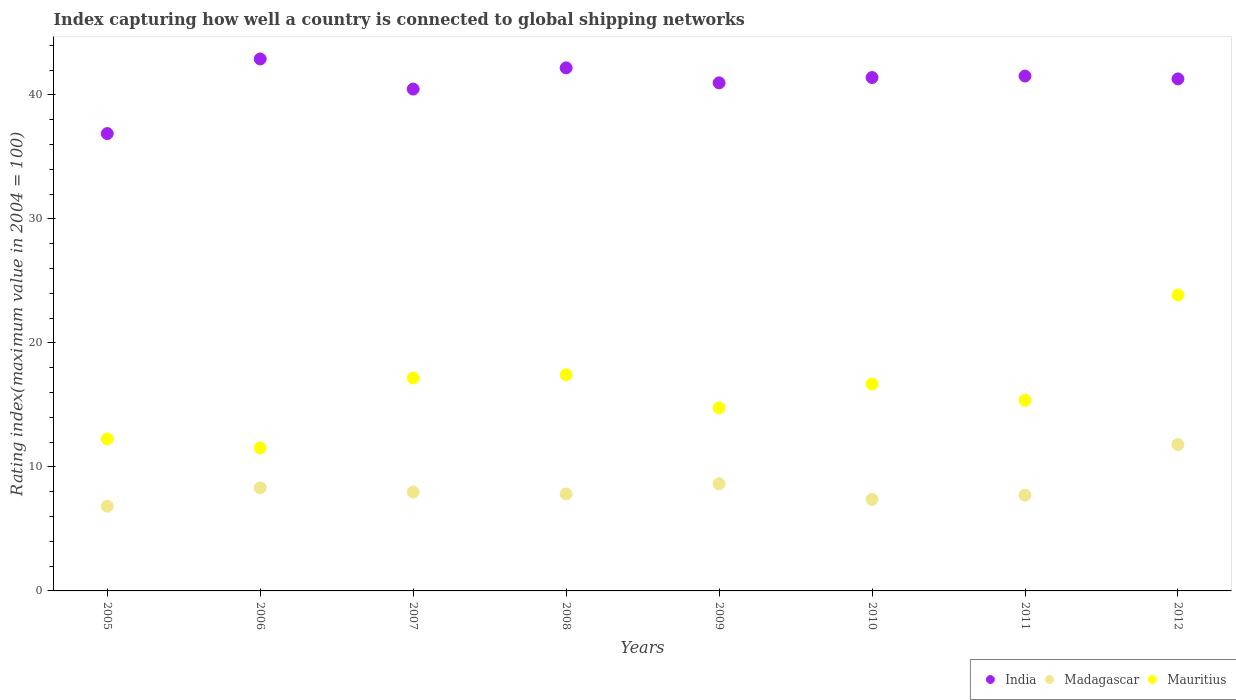How many different coloured dotlines are there?
Ensure brevity in your answer.  3. Is the number of dotlines equal to the number of legend labels?
Your response must be concise. Yes. What is the rating index in Madagascar in 2012?
Provide a short and direct response. 11.8. Across all years, what is the maximum rating index in Madagascar?
Provide a succinct answer. 11.8. Across all years, what is the minimum rating index in Madagascar?
Offer a very short reply. 6.83. In which year was the rating index in Madagascar maximum?
Your response must be concise. 2012. What is the total rating index in Mauritius in the graph?
Your answer should be very brief. 129.06. What is the difference between the rating index in Madagascar in 2007 and that in 2012?
Offer a terse response. -3.83. What is the difference between the rating index in India in 2011 and the rating index in Mauritius in 2007?
Offer a terse response. 24.35. What is the average rating index in Madagascar per year?
Ensure brevity in your answer.  8.31. In the year 2005, what is the difference between the rating index in India and rating index in Mauritius?
Your answer should be very brief. 24.62. In how many years, is the rating index in India greater than 40?
Offer a terse response. 7. What is the ratio of the rating index in Madagascar in 2007 to that in 2009?
Provide a succinct answer. 0.92. What is the difference between the highest and the second highest rating index in India?
Keep it short and to the point. 0.72. What is the difference between the highest and the lowest rating index in Madagascar?
Your answer should be compact. 4.97. In how many years, is the rating index in Mauritius greater than the average rating index in Mauritius taken over all years?
Your answer should be very brief. 4. Is it the case that in every year, the sum of the rating index in Mauritius and rating index in Madagascar  is greater than the rating index in India?
Ensure brevity in your answer.  No. Does the rating index in Mauritius monotonically increase over the years?
Offer a terse response. No. Is the rating index in India strictly less than the rating index in Madagascar over the years?
Make the answer very short. No. How many dotlines are there?
Your response must be concise. 3. Does the graph contain grids?
Make the answer very short. No. How many legend labels are there?
Make the answer very short. 3. What is the title of the graph?
Give a very brief answer. Index capturing how well a country is connected to global shipping networks. Does "High income: nonOECD" appear as one of the legend labels in the graph?
Your answer should be very brief. No. What is the label or title of the Y-axis?
Your answer should be compact. Rating index(maximum value in 2004 = 100). What is the Rating index(maximum value in 2004 = 100) in India in 2005?
Provide a succinct answer. 36.88. What is the Rating index(maximum value in 2004 = 100) of Madagascar in 2005?
Ensure brevity in your answer.  6.83. What is the Rating index(maximum value in 2004 = 100) of Mauritius in 2005?
Provide a short and direct response. 12.26. What is the Rating index(maximum value in 2004 = 100) in India in 2006?
Provide a short and direct response. 42.9. What is the Rating index(maximum value in 2004 = 100) of Madagascar in 2006?
Ensure brevity in your answer.  8.31. What is the Rating index(maximum value in 2004 = 100) of Mauritius in 2006?
Make the answer very short. 11.53. What is the Rating index(maximum value in 2004 = 100) in India in 2007?
Ensure brevity in your answer.  40.47. What is the Rating index(maximum value in 2004 = 100) of Madagascar in 2007?
Offer a terse response. 7.97. What is the Rating index(maximum value in 2004 = 100) in Mauritius in 2007?
Offer a very short reply. 17.17. What is the Rating index(maximum value in 2004 = 100) of India in 2008?
Your response must be concise. 42.18. What is the Rating index(maximum value in 2004 = 100) in Madagascar in 2008?
Provide a succinct answer. 7.82. What is the Rating index(maximum value in 2004 = 100) of Mauritius in 2008?
Provide a short and direct response. 17.43. What is the Rating index(maximum value in 2004 = 100) of India in 2009?
Give a very brief answer. 40.97. What is the Rating index(maximum value in 2004 = 100) of Madagascar in 2009?
Your response must be concise. 8.64. What is the Rating index(maximum value in 2004 = 100) of Mauritius in 2009?
Make the answer very short. 14.76. What is the Rating index(maximum value in 2004 = 100) in India in 2010?
Keep it short and to the point. 41.4. What is the Rating index(maximum value in 2004 = 100) in Madagascar in 2010?
Offer a very short reply. 7.38. What is the Rating index(maximum value in 2004 = 100) in Mauritius in 2010?
Your answer should be very brief. 16.68. What is the Rating index(maximum value in 2004 = 100) of India in 2011?
Your answer should be compact. 41.52. What is the Rating index(maximum value in 2004 = 100) of Madagascar in 2011?
Make the answer very short. 7.72. What is the Rating index(maximum value in 2004 = 100) of Mauritius in 2011?
Your answer should be compact. 15.37. What is the Rating index(maximum value in 2004 = 100) of India in 2012?
Ensure brevity in your answer.  41.29. What is the Rating index(maximum value in 2004 = 100) of Mauritius in 2012?
Make the answer very short. 23.86. Across all years, what is the maximum Rating index(maximum value in 2004 = 100) of India?
Provide a succinct answer. 42.9. Across all years, what is the maximum Rating index(maximum value in 2004 = 100) in Madagascar?
Provide a succinct answer. 11.8. Across all years, what is the maximum Rating index(maximum value in 2004 = 100) of Mauritius?
Offer a very short reply. 23.86. Across all years, what is the minimum Rating index(maximum value in 2004 = 100) in India?
Keep it short and to the point. 36.88. Across all years, what is the minimum Rating index(maximum value in 2004 = 100) of Madagascar?
Ensure brevity in your answer.  6.83. Across all years, what is the minimum Rating index(maximum value in 2004 = 100) in Mauritius?
Your response must be concise. 11.53. What is the total Rating index(maximum value in 2004 = 100) in India in the graph?
Your response must be concise. 327.61. What is the total Rating index(maximum value in 2004 = 100) of Madagascar in the graph?
Offer a terse response. 66.47. What is the total Rating index(maximum value in 2004 = 100) in Mauritius in the graph?
Offer a terse response. 129.06. What is the difference between the Rating index(maximum value in 2004 = 100) in India in 2005 and that in 2006?
Ensure brevity in your answer.  -6.02. What is the difference between the Rating index(maximum value in 2004 = 100) in Madagascar in 2005 and that in 2006?
Offer a very short reply. -1.48. What is the difference between the Rating index(maximum value in 2004 = 100) in Mauritius in 2005 and that in 2006?
Provide a succinct answer. 0.73. What is the difference between the Rating index(maximum value in 2004 = 100) of India in 2005 and that in 2007?
Ensure brevity in your answer.  -3.59. What is the difference between the Rating index(maximum value in 2004 = 100) of Madagascar in 2005 and that in 2007?
Offer a very short reply. -1.14. What is the difference between the Rating index(maximum value in 2004 = 100) in Mauritius in 2005 and that in 2007?
Offer a very short reply. -4.91. What is the difference between the Rating index(maximum value in 2004 = 100) of India in 2005 and that in 2008?
Keep it short and to the point. -5.3. What is the difference between the Rating index(maximum value in 2004 = 100) in Madagascar in 2005 and that in 2008?
Make the answer very short. -0.99. What is the difference between the Rating index(maximum value in 2004 = 100) in Mauritius in 2005 and that in 2008?
Keep it short and to the point. -5.17. What is the difference between the Rating index(maximum value in 2004 = 100) in India in 2005 and that in 2009?
Make the answer very short. -4.09. What is the difference between the Rating index(maximum value in 2004 = 100) in Madagascar in 2005 and that in 2009?
Your response must be concise. -1.81. What is the difference between the Rating index(maximum value in 2004 = 100) of Mauritius in 2005 and that in 2009?
Offer a terse response. -2.5. What is the difference between the Rating index(maximum value in 2004 = 100) of India in 2005 and that in 2010?
Keep it short and to the point. -4.52. What is the difference between the Rating index(maximum value in 2004 = 100) in Madagascar in 2005 and that in 2010?
Your answer should be compact. -0.55. What is the difference between the Rating index(maximum value in 2004 = 100) of Mauritius in 2005 and that in 2010?
Your response must be concise. -4.42. What is the difference between the Rating index(maximum value in 2004 = 100) of India in 2005 and that in 2011?
Keep it short and to the point. -4.64. What is the difference between the Rating index(maximum value in 2004 = 100) of Madagascar in 2005 and that in 2011?
Give a very brief answer. -0.89. What is the difference between the Rating index(maximum value in 2004 = 100) of Mauritius in 2005 and that in 2011?
Make the answer very short. -3.11. What is the difference between the Rating index(maximum value in 2004 = 100) of India in 2005 and that in 2012?
Offer a terse response. -4.41. What is the difference between the Rating index(maximum value in 2004 = 100) of Madagascar in 2005 and that in 2012?
Keep it short and to the point. -4.97. What is the difference between the Rating index(maximum value in 2004 = 100) in Mauritius in 2005 and that in 2012?
Offer a terse response. -11.6. What is the difference between the Rating index(maximum value in 2004 = 100) in India in 2006 and that in 2007?
Provide a succinct answer. 2.43. What is the difference between the Rating index(maximum value in 2004 = 100) of Madagascar in 2006 and that in 2007?
Make the answer very short. 0.34. What is the difference between the Rating index(maximum value in 2004 = 100) in Mauritius in 2006 and that in 2007?
Your answer should be compact. -5.64. What is the difference between the Rating index(maximum value in 2004 = 100) of India in 2006 and that in 2008?
Your response must be concise. 0.72. What is the difference between the Rating index(maximum value in 2004 = 100) of Madagascar in 2006 and that in 2008?
Ensure brevity in your answer.  0.49. What is the difference between the Rating index(maximum value in 2004 = 100) of India in 2006 and that in 2009?
Offer a terse response. 1.93. What is the difference between the Rating index(maximum value in 2004 = 100) of Madagascar in 2006 and that in 2009?
Give a very brief answer. -0.33. What is the difference between the Rating index(maximum value in 2004 = 100) in Mauritius in 2006 and that in 2009?
Your response must be concise. -3.23. What is the difference between the Rating index(maximum value in 2004 = 100) of Madagascar in 2006 and that in 2010?
Your response must be concise. 0.93. What is the difference between the Rating index(maximum value in 2004 = 100) of Mauritius in 2006 and that in 2010?
Your answer should be very brief. -5.15. What is the difference between the Rating index(maximum value in 2004 = 100) of India in 2006 and that in 2011?
Provide a succinct answer. 1.38. What is the difference between the Rating index(maximum value in 2004 = 100) of Madagascar in 2006 and that in 2011?
Provide a succinct answer. 0.59. What is the difference between the Rating index(maximum value in 2004 = 100) in Mauritius in 2006 and that in 2011?
Offer a terse response. -3.84. What is the difference between the Rating index(maximum value in 2004 = 100) of India in 2006 and that in 2012?
Give a very brief answer. 1.61. What is the difference between the Rating index(maximum value in 2004 = 100) in Madagascar in 2006 and that in 2012?
Offer a very short reply. -3.49. What is the difference between the Rating index(maximum value in 2004 = 100) in Mauritius in 2006 and that in 2012?
Provide a succinct answer. -12.33. What is the difference between the Rating index(maximum value in 2004 = 100) of India in 2007 and that in 2008?
Provide a short and direct response. -1.71. What is the difference between the Rating index(maximum value in 2004 = 100) in Mauritius in 2007 and that in 2008?
Offer a very short reply. -0.26. What is the difference between the Rating index(maximum value in 2004 = 100) of India in 2007 and that in 2009?
Your answer should be compact. -0.5. What is the difference between the Rating index(maximum value in 2004 = 100) of Madagascar in 2007 and that in 2009?
Provide a succinct answer. -0.67. What is the difference between the Rating index(maximum value in 2004 = 100) in Mauritius in 2007 and that in 2009?
Make the answer very short. 2.41. What is the difference between the Rating index(maximum value in 2004 = 100) of India in 2007 and that in 2010?
Ensure brevity in your answer.  -0.93. What is the difference between the Rating index(maximum value in 2004 = 100) of Madagascar in 2007 and that in 2010?
Your answer should be compact. 0.59. What is the difference between the Rating index(maximum value in 2004 = 100) of Mauritius in 2007 and that in 2010?
Your response must be concise. 0.49. What is the difference between the Rating index(maximum value in 2004 = 100) of India in 2007 and that in 2011?
Your answer should be very brief. -1.05. What is the difference between the Rating index(maximum value in 2004 = 100) in Mauritius in 2007 and that in 2011?
Give a very brief answer. 1.8. What is the difference between the Rating index(maximum value in 2004 = 100) in India in 2007 and that in 2012?
Provide a succinct answer. -0.82. What is the difference between the Rating index(maximum value in 2004 = 100) in Madagascar in 2007 and that in 2012?
Keep it short and to the point. -3.83. What is the difference between the Rating index(maximum value in 2004 = 100) of Mauritius in 2007 and that in 2012?
Keep it short and to the point. -6.69. What is the difference between the Rating index(maximum value in 2004 = 100) in India in 2008 and that in 2009?
Give a very brief answer. 1.21. What is the difference between the Rating index(maximum value in 2004 = 100) in Madagascar in 2008 and that in 2009?
Offer a very short reply. -0.82. What is the difference between the Rating index(maximum value in 2004 = 100) of Mauritius in 2008 and that in 2009?
Ensure brevity in your answer.  2.67. What is the difference between the Rating index(maximum value in 2004 = 100) in India in 2008 and that in 2010?
Your answer should be compact. 0.78. What is the difference between the Rating index(maximum value in 2004 = 100) of Madagascar in 2008 and that in 2010?
Ensure brevity in your answer.  0.44. What is the difference between the Rating index(maximum value in 2004 = 100) of India in 2008 and that in 2011?
Your response must be concise. 0.66. What is the difference between the Rating index(maximum value in 2004 = 100) of Madagascar in 2008 and that in 2011?
Provide a short and direct response. 0.1. What is the difference between the Rating index(maximum value in 2004 = 100) of Mauritius in 2008 and that in 2011?
Your response must be concise. 2.06. What is the difference between the Rating index(maximum value in 2004 = 100) in India in 2008 and that in 2012?
Ensure brevity in your answer.  0.89. What is the difference between the Rating index(maximum value in 2004 = 100) in Madagascar in 2008 and that in 2012?
Give a very brief answer. -3.98. What is the difference between the Rating index(maximum value in 2004 = 100) of Mauritius in 2008 and that in 2012?
Provide a succinct answer. -6.43. What is the difference between the Rating index(maximum value in 2004 = 100) of India in 2009 and that in 2010?
Offer a terse response. -0.43. What is the difference between the Rating index(maximum value in 2004 = 100) of Madagascar in 2009 and that in 2010?
Make the answer very short. 1.26. What is the difference between the Rating index(maximum value in 2004 = 100) of Mauritius in 2009 and that in 2010?
Offer a terse response. -1.92. What is the difference between the Rating index(maximum value in 2004 = 100) in India in 2009 and that in 2011?
Give a very brief answer. -0.55. What is the difference between the Rating index(maximum value in 2004 = 100) in Madagascar in 2009 and that in 2011?
Keep it short and to the point. 0.92. What is the difference between the Rating index(maximum value in 2004 = 100) in Mauritius in 2009 and that in 2011?
Your answer should be very brief. -0.61. What is the difference between the Rating index(maximum value in 2004 = 100) in India in 2009 and that in 2012?
Give a very brief answer. -0.32. What is the difference between the Rating index(maximum value in 2004 = 100) of Madagascar in 2009 and that in 2012?
Make the answer very short. -3.16. What is the difference between the Rating index(maximum value in 2004 = 100) of India in 2010 and that in 2011?
Give a very brief answer. -0.12. What is the difference between the Rating index(maximum value in 2004 = 100) in Madagascar in 2010 and that in 2011?
Give a very brief answer. -0.34. What is the difference between the Rating index(maximum value in 2004 = 100) of Mauritius in 2010 and that in 2011?
Your answer should be compact. 1.31. What is the difference between the Rating index(maximum value in 2004 = 100) in India in 2010 and that in 2012?
Ensure brevity in your answer.  0.11. What is the difference between the Rating index(maximum value in 2004 = 100) in Madagascar in 2010 and that in 2012?
Keep it short and to the point. -4.42. What is the difference between the Rating index(maximum value in 2004 = 100) of Mauritius in 2010 and that in 2012?
Your answer should be very brief. -7.18. What is the difference between the Rating index(maximum value in 2004 = 100) in India in 2011 and that in 2012?
Provide a short and direct response. 0.23. What is the difference between the Rating index(maximum value in 2004 = 100) of Madagascar in 2011 and that in 2012?
Make the answer very short. -4.08. What is the difference between the Rating index(maximum value in 2004 = 100) of Mauritius in 2011 and that in 2012?
Make the answer very short. -8.49. What is the difference between the Rating index(maximum value in 2004 = 100) in India in 2005 and the Rating index(maximum value in 2004 = 100) in Madagascar in 2006?
Your response must be concise. 28.57. What is the difference between the Rating index(maximum value in 2004 = 100) of India in 2005 and the Rating index(maximum value in 2004 = 100) of Mauritius in 2006?
Your answer should be very brief. 25.35. What is the difference between the Rating index(maximum value in 2004 = 100) of Madagascar in 2005 and the Rating index(maximum value in 2004 = 100) of Mauritius in 2006?
Your answer should be compact. -4.7. What is the difference between the Rating index(maximum value in 2004 = 100) in India in 2005 and the Rating index(maximum value in 2004 = 100) in Madagascar in 2007?
Your answer should be very brief. 28.91. What is the difference between the Rating index(maximum value in 2004 = 100) in India in 2005 and the Rating index(maximum value in 2004 = 100) in Mauritius in 2007?
Ensure brevity in your answer.  19.71. What is the difference between the Rating index(maximum value in 2004 = 100) in Madagascar in 2005 and the Rating index(maximum value in 2004 = 100) in Mauritius in 2007?
Provide a short and direct response. -10.34. What is the difference between the Rating index(maximum value in 2004 = 100) of India in 2005 and the Rating index(maximum value in 2004 = 100) of Madagascar in 2008?
Make the answer very short. 29.06. What is the difference between the Rating index(maximum value in 2004 = 100) of India in 2005 and the Rating index(maximum value in 2004 = 100) of Mauritius in 2008?
Provide a succinct answer. 19.45. What is the difference between the Rating index(maximum value in 2004 = 100) of Madagascar in 2005 and the Rating index(maximum value in 2004 = 100) of Mauritius in 2008?
Your answer should be very brief. -10.6. What is the difference between the Rating index(maximum value in 2004 = 100) in India in 2005 and the Rating index(maximum value in 2004 = 100) in Madagascar in 2009?
Offer a terse response. 28.24. What is the difference between the Rating index(maximum value in 2004 = 100) of India in 2005 and the Rating index(maximum value in 2004 = 100) of Mauritius in 2009?
Give a very brief answer. 22.12. What is the difference between the Rating index(maximum value in 2004 = 100) of Madagascar in 2005 and the Rating index(maximum value in 2004 = 100) of Mauritius in 2009?
Your answer should be compact. -7.93. What is the difference between the Rating index(maximum value in 2004 = 100) in India in 2005 and the Rating index(maximum value in 2004 = 100) in Madagascar in 2010?
Provide a short and direct response. 29.5. What is the difference between the Rating index(maximum value in 2004 = 100) in India in 2005 and the Rating index(maximum value in 2004 = 100) in Mauritius in 2010?
Give a very brief answer. 20.2. What is the difference between the Rating index(maximum value in 2004 = 100) of Madagascar in 2005 and the Rating index(maximum value in 2004 = 100) of Mauritius in 2010?
Your answer should be compact. -9.85. What is the difference between the Rating index(maximum value in 2004 = 100) in India in 2005 and the Rating index(maximum value in 2004 = 100) in Madagascar in 2011?
Provide a short and direct response. 29.16. What is the difference between the Rating index(maximum value in 2004 = 100) in India in 2005 and the Rating index(maximum value in 2004 = 100) in Mauritius in 2011?
Provide a succinct answer. 21.51. What is the difference between the Rating index(maximum value in 2004 = 100) in Madagascar in 2005 and the Rating index(maximum value in 2004 = 100) in Mauritius in 2011?
Provide a succinct answer. -8.54. What is the difference between the Rating index(maximum value in 2004 = 100) in India in 2005 and the Rating index(maximum value in 2004 = 100) in Madagascar in 2012?
Offer a terse response. 25.08. What is the difference between the Rating index(maximum value in 2004 = 100) in India in 2005 and the Rating index(maximum value in 2004 = 100) in Mauritius in 2012?
Give a very brief answer. 13.02. What is the difference between the Rating index(maximum value in 2004 = 100) in Madagascar in 2005 and the Rating index(maximum value in 2004 = 100) in Mauritius in 2012?
Give a very brief answer. -17.03. What is the difference between the Rating index(maximum value in 2004 = 100) of India in 2006 and the Rating index(maximum value in 2004 = 100) of Madagascar in 2007?
Offer a very short reply. 34.93. What is the difference between the Rating index(maximum value in 2004 = 100) of India in 2006 and the Rating index(maximum value in 2004 = 100) of Mauritius in 2007?
Give a very brief answer. 25.73. What is the difference between the Rating index(maximum value in 2004 = 100) of Madagascar in 2006 and the Rating index(maximum value in 2004 = 100) of Mauritius in 2007?
Make the answer very short. -8.86. What is the difference between the Rating index(maximum value in 2004 = 100) in India in 2006 and the Rating index(maximum value in 2004 = 100) in Madagascar in 2008?
Your answer should be compact. 35.08. What is the difference between the Rating index(maximum value in 2004 = 100) in India in 2006 and the Rating index(maximum value in 2004 = 100) in Mauritius in 2008?
Make the answer very short. 25.47. What is the difference between the Rating index(maximum value in 2004 = 100) of Madagascar in 2006 and the Rating index(maximum value in 2004 = 100) of Mauritius in 2008?
Offer a very short reply. -9.12. What is the difference between the Rating index(maximum value in 2004 = 100) in India in 2006 and the Rating index(maximum value in 2004 = 100) in Madagascar in 2009?
Your answer should be very brief. 34.26. What is the difference between the Rating index(maximum value in 2004 = 100) of India in 2006 and the Rating index(maximum value in 2004 = 100) of Mauritius in 2009?
Keep it short and to the point. 28.14. What is the difference between the Rating index(maximum value in 2004 = 100) in Madagascar in 2006 and the Rating index(maximum value in 2004 = 100) in Mauritius in 2009?
Your answer should be compact. -6.45. What is the difference between the Rating index(maximum value in 2004 = 100) in India in 2006 and the Rating index(maximum value in 2004 = 100) in Madagascar in 2010?
Your answer should be compact. 35.52. What is the difference between the Rating index(maximum value in 2004 = 100) of India in 2006 and the Rating index(maximum value in 2004 = 100) of Mauritius in 2010?
Keep it short and to the point. 26.22. What is the difference between the Rating index(maximum value in 2004 = 100) of Madagascar in 2006 and the Rating index(maximum value in 2004 = 100) of Mauritius in 2010?
Your answer should be very brief. -8.37. What is the difference between the Rating index(maximum value in 2004 = 100) in India in 2006 and the Rating index(maximum value in 2004 = 100) in Madagascar in 2011?
Make the answer very short. 35.18. What is the difference between the Rating index(maximum value in 2004 = 100) in India in 2006 and the Rating index(maximum value in 2004 = 100) in Mauritius in 2011?
Ensure brevity in your answer.  27.53. What is the difference between the Rating index(maximum value in 2004 = 100) of Madagascar in 2006 and the Rating index(maximum value in 2004 = 100) of Mauritius in 2011?
Provide a short and direct response. -7.06. What is the difference between the Rating index(maximum value in 2004 = 100) of India in 2006 and the Rating index(maximum value in 2004 = 100) of Madagascar in 2012?
Offer a very short reply. 31.1. What is the difference between the Rating index(maximum value in 2004 = 100) of India in 2006 and the Rating index(maximum value in 2004 = 100) of Mauritius in 2012?
Offer a terse response. 19.04. What is the difference between the Rating index(maximum value in 2004 = 100) in Madagascar in 2006 and the Rating index(maximum value in 2004 = 100) in Mauritius in 2012?
Make the answer very short. -15.55. What is the difference between the Rating index(maximum value in 2004 = 100) in India in 2007 and the Rating index(maximum value in 2004 = 100) in Madagascar in 2008?
Provide a short and direct response. 32.65. What is the difference between the Rating index(maximum value in 2004 = 100) in India in 2007 and the Rating index(maximum value in 2004 = 100) in Mauritius in 2008?
Offer a very short reply. 23.04. What is the difference between the Rating index(maximum value in 2004 = 100) in Madagascar in 2007 and the Rating index(maximum value in 2004 = 100) in Mauritius in 2008?
Make the answer very short. -9.46. What is the difference between the Rating index(maximum value in 2004 = 100) in India in 2007 and the Rating index(maximum value in 2004 = 100) in Madagascar in 2009?
Provide a succinct answer. 31.83. What is the difference between the Rating index(maximum value in 2004 = 100) of India in 2007 and the Rating index(maximum value in 2004 = 100) of Mauritius in 2009?
Make the answer very short. 25.71. What is the difference between the Rating index(maximum value in 2004 = 100) in Madagascar in 2007 and the Rating index(maximum value in 2004 = 100) in Mauritius in 2009?
Ensure brevity in your answer.  -6.79. What is the difference between the Rating index(maximum value in 2004 = 100) of India in 2007 and the Rating index(maximum value in 2004 = 100) of Madagascar in 2010?
Provide a short and direct response. 33.09. What is the difference between the Rating index(maximum value in 2004 = 100) in India in 2007 and the Rating index(maximum value in 2004 = 100) in Mauritius in 2010?
Provide a succinct answer. 23.79. What is the difference between the Rating index(maximum value in 2004 = 100) of Madagascar in 2007 and the Rating index(maximum value in 2004 = 100) of Mauritius in 2010?
Provide a short and direct response. -8.71. What is the difference between the Rating index(maximum value in 2004 = 100) of India in 2007 and the Rating index(maximum value in 2004 = 100) of Madagascar in 2011?
Offer a terse response. 32.75. What is the difference between the Rating index(maximum value in 2004 = 100) in India in 2007 and the Rating index(maximum value in 2004 = 100) in Mauritius in 2011?
Provide a short and direct response. 25.1. What is the difference between the Rating index(maximum value in 2004 = 100) in India in 2007 and the Rating index(maximum value in 2004 = 100) in Madagascar in 2012?
Make the answer very short. 28.67. What is the difference between the Rating index(maximum value in 2004 = 100) in India in 2007 and the Rating index(maximum value in 2004 = 100) in Mauritius in 2012?
Offer a very short reply. 16.61. What is the difference between the Rating index(maximum value in 2004 = 100) in Madagascar in 2007 and the Rating index(maximum value in 2004 = 100) in Mauritius in 2012?
Provide a succinct answer. -15.89. What is the difference between the Rating index(maximum value in 2004 = 100) in India in 2008 and the Rating index(maximum value in 2004 = 100) in Madagascar in 2009?
Offer a terse response. 33.54. What is the difference between the Rating index(maximum value in 2004 = 100) in India in 2008 and the Rating index(maximum value in 2004 = 100) in Mauritius in 2009?
Your response must be concise. 27.42. What is the difference between the Rating index(maximum value in 2004 = 100) in Madagascar in 2008 and the Rating index(maximum value in 2004 = 100) in Mauritius in 2009?
Give a very brief answer. -6.94. What is the difference between the Rating index(maximum value in 2004 = 100) in India in 2008 and the Rating index(maximum value in 2004 = 100) in Madagascar in 2010?
Ensure brevity in your answer.  34.8. What is the difference between the Rating index(maximum value in 2004 = 100) of Madagascar in 2008 and the Rating index(maximum value in 2004 = 100) of Mauritius in 2010?
Your answer should be very brief. -8.86. What is the difference between the Rating index(maximum value in 2004 = 100) in India in 2008 and the Rating index(maximum value in 2004 = 100) in Madagascar in 2011?
Your answer should be very brief. 34.46. What is the difference between the Rating index(maximum value in 2004 = 100) of India in 2008 and the Rating index(maximum value in 2004 = 100) of Mauritius in 2011?
Your answer should be compact. 26.81. What is the difference between the Rating index(maximum value in 2004 = 100) in Madagascar in 2008 and the Rating index(maximum value in 2004 = 100) in Mauritius in 2011?
Your answer should be compact. -7.55. What is the difference between the Rating index(maximum value in 2004 = 100) in India in 2008 and the Rating index(maximum value in 2004 = 100) in Madagascar in 2012?
Offer a terse response. 30.38. What is the difference between the Rating index(maximum value in 2004 = 100) of India in 2008 and the Rating index(maximum value in 2004 = 100) of Mauritius in 2012?
Ensure brevity in your answer.  18.32. What is the difference between the Rating index(maximum value in 2004 = 100) in Madagascar in 2008 and the Rating index(maximum value in 2004 = 100) in Mauritius in 2012?
Make the answer very short. -16.04. What is the difference between the Rating index(maximum value in 2004 = 100) of India in 2009 and the Rating index(maximum value in 2004 = 100) of Madagascar in 2010?
Make the answer very short. 33.59. What is the difference between the Rating index(maximum value in 2004 = 100) of India in 2009 and the Rating index(maximum value in 2004 = 100) of Mauritius in 2010?
Your answer should be very brief. 24.29. What is the difference between the Rating index(maximum value in 2004 = 100) in Madagascar in 2009 and the Rating index(maximum value in 2004 = 100) in Mauritius in 2010?
Ensure brevity in your answer.  -8.04. What is the difference between the Rating index(maximum value in 2004 = 100) of India in 2009 and the Rating index(maximum value in 2004 = 100) of Madagascar in 2011?
Offer a very short reply. 33.25. What is the difference between the Rating index(maximum value in 2004 = 100) in India in 2009 and the Rating index(maximum value in 2004 = 100) in Mauritius in 2011?
Your answer should be very brief. 25.6. What is the difference between the Rating index(maximum value in 2004 = 100) of Madagascar in 2009 and the Rating index(maximum value in 2004 = 100) of Mauritius in 2011?
Provide a succinct answer. -6.73. What is the difference between the Rating index(maximum value in 2004 = 100) in India in 2009 and the Rating index(maximum value in 2004 = 100) in Madagascar in 2012?
Offer a very short reply. 29.17. What is the difference between the Rating index(maximum value in 2004 = 100) in India in 2009 and the Rating index(maximum value in 2004 = 100) in Mauritius in 2012?
Make the answer very short. 17.11. What is the difference between the Rating index(maximum value in 2004 = 100) in Madagascar in 2009 and the Rating index(maximum value in 2004 = 100) in Mauritius in 2012?
Give a very brief answer. -15.22. What is the difference between the Rating index(maximum value in 2004 = 100) in India in 2010 and the Rating index(maximum value in 2004 = 100) in Madagascar in 2011?
Keep it short and to the point. 33.68. What is the difference between the Rating index(maximum value in 2004 = 100) of India in 2010 and the Rating index(maximum value in 2004 = 100) of Mauritius in 2011?
Ensure brevity in your answer.  26.03. What is the difference between the Rating index(maximum value in 2004 = 100) of Madagascar in 2010 and the Rating index(maximum value in 2004 = 100) of Mauritius in 2011?
Offer a terse response. -7.99. What is the difference between the Rating index(maximum value in 2004 = 100) in India in 2010 and the Rating index(maximum value in 2004 = 100) in Madagascar in 2012?
Offer a very short reply. 29.6. What is the difference between the Rating index(maximum value in 2004 = 100) of India in 2010 and the Rating index(maximum value in 2004 = 100) of Mauritius in 2012?
Provide a succinct answer. 17.54. What is the difference between the Rating index(maximum value in 2004 = 100) of Madagascar in 2010 and the Rating index(maximum value in 2004 = 100) of Mauritius in 2012?
Give a very brief answer. -16.48. What is the difference between the Rating index(maximum value in 2004 = 100) in India in 2011 and the Rating index(maximum value in 2004 = 100) in Madagascar in 2012?
Your answer should be very brief. 29.72. What is the difference between the Rating index(maximum value in 2004 = 100) of India in 2011 and the Rating index(maximum value in 2004 = 100) of Mauritius in 2012?
Your answer should be very brief. 17.66. What is the difference between the Rating index(maximum value in 2004 = 100) in Madagascar in 2011 and the Rating index(maximum value in 2004 = 100) in Mauritius in 2012?
Offer a very short reply. -16.14. What is the average Rating index(maximum value in 2004 = 100) in India per year?
Your response must be concise. 40.95. What is the average Rating index(maximum value in 2004 = 100) in Madagascar per year?
Provide a succinct answer. 8.31. What is the average Rating index(maximum value in 2004 = 100) of Mauritius per year?
Your response must be concise. 16.13. In the year 2005, what is the difference between the Rating index(maximum value in 2004 = 100) in India and Rating index(maximum value in 2004 = 100) in Madagascar?
Offer a very short reply. 30.05. In the year 2005, what is the difference between the Rating index(maximum value in 2004 = 100) in India and Rating index(maximum value in 2004 = 100) in Mauritius?
Your answer should be very brief. 24.62. In the year 2005, what is the difference between the Rating index(maximum value in 2004 = 100) in Madagascar and Rating index(maximum value in 2004 = 100) in Mauritius?
Give a very brief answer. -5.43. In the year 2006, what is the difference between the Rating index(maximum value in 2004 = 100) of India and Rating index(maximum value in 2004 = 100) of Madagascar?
Keep it short and to the point. 34.59. In the year 2006, what is the difference between the Rating index(maximum value in 2004 = 100) of India and Rating index(maximum value in 2004 = 100) of Mauritius?
Keep it short and to the point. 31.37. In the year 2006, what is the difference between the Rating index(maximum value in 2004 = 100) of Madagascar and Rating index(maximum value in 2004 = 100) of Mauritius?
Offer a very short reply. -3.22. In the year 2007, what is the difference between the Rating index(maximum value in 2004 = 100) in India and Rating index(maximum value in 2004 = 100) in Madagascar?
Your answer should be compact. 32.5. In the year 2007, what is the difference between the Rating index(maximum value in 2004 = 100) in India and Rating index(maximum value in 2004 = 100) in Mauritius?
Keep it short and to the point. 23.3. In the year 2008, what is the difference between the Rating index(maximum value in 2004 = 100) of India and Rating index(maximum value in 2004 = 100) of Madagascar?
Offer a very short reply. 34.36. In the year 2008, what is the difference between the Rating index(maximum value in 2004 = 100) of India and Rating index(maximum value in 2004 = 100) of Mauritius?
Provide a short and direct response. 24.75. In the year 2008, what is the difference between the Rating index(maximum value in 2004 = 100) in Madagascar and Rating index(maximum value in 2004 = 100) in Mauritius?
Make the answer very short. -9.61. In the year 2009, what is the difference between the Rating index(maximum value in 2004 = 100) in India and Rating index(maximum value in 2004 = 100) in Madagascar?
Give a very brief answer. 32.33. In the year 2009, what is the difference between the Rating index(maximum value in 2004 = 100) in India and Rating index(maximum value in 2004 = 100) in Mauritius?
Make the answer very short. 26.21. In the year 2009, what is the difference between the Rating index(maximum value in 2004 = 100) of Madagascar and Rating index(maximum value in 2004 = 100) of Mauritius?
Give a very brief answer. -6.12. In the year 2010, what is the difference between the Rating index(maximum value in 2004 = 100) of India and Rating index(maximum value in 2004 = 100) of Madagascar?
Your response must be concise. 34.02. In the year 2010, what is the difference between the Rating index(maximum value in 2004 = 100) of India and Rating index(maximum value in 2004 = 100) of Mauritius?
Ensure brevity in your answer.  24.72. In the year 2011, what is the difference between the Rating index(maximum value in 2004 = 100) in India and Rating index(maximum value in 2004 = 100) in Madagascar?
Keep it short and to the point. 33.8. In the year 2011, what is the difference between the Rating index(maximum value in 2004 = 100) of India and Rating index(maximum value in 2004 = 100) of Mauritius?
Your answer should be very brief. 26.15. In the year 2011, what is the difference between the Rating index(maximum value in 2004 = 100) of Madagascar and Rating index(maximum value in 2004 = 100) of Mauritius?
Make the answer very short. -7.65. In the year 2012, what is the difference between the Rating index(maximum value in 2004 = 100) in India and Rating index(maximum value in 2004 = 100) in Madagascar?
Make the answer very short. 29.49. In the year 2012, what is the difference between the Rating index(maximum value in 2004 = 100) of India and Rating index(maximum value in 2004 = 100) of Mauritius?
Ensure brevity in your answer.  17.43. In the year 2012, what is the difference between the Rating index(maximum value in 2004 = 100) in Madagascar and Rating index(maximum value in 2004 = 100) in Mauritius?
Provide a succinct answer. -12.06. What is the ratio of the Rating index(maximum value in 2004 = 100) in India in 2005 to that in 2006?
Your answer should be compact. 0.86. What is the ratio of the Rating index(maximum value in 2004 = 100) in Madagascar in 2005 to that in 2006?
Offer a very short reply. 0.82. What is the ratio of the Rating index(maximum value in 2004 = 100) of Mauritius in 2005 to that in 2006?
Your answer should be compact. 1.06. What is the ratio of the Rating index(maximum value in 2004 = 100) of India in 2005 to that in 2007?
Make the answer very short. 0.91. What is the ratio of the Rating index(maximum value in 2004 = 100) in Madagascar in 2005 to that in 2007?
Give a very brief answer. 0.86. What is the ratio of the Rating index(maximum value in 2004 = 100) in Mauritius in 2005 to that in 2007?
Give a very brief answer. 0.71. What is the ratio of the Rating index(maximum value in 2004 = 100) of India in 2005 to that in 2008?
Keep it short and to the point. 0.87. What is the ratio of the Rating index(maximum value in 2004 = 100) of Madagascar in 2005 to that in 2008?
Your response must be concise. 0.87. What is the ratio of the Rating index(maximum value in 2004 = 100) in Mauritius in 2005 to that in 2008?
Ensure brevity in your answer.  0.7. What is the ratio of the Rating index(maximum value in 2004 = 100) in India in 2005 to that in 2009?
Provide a succinct answer. 0.9. What is the ratio of the Rating index(maximum value in 2004 = 100) of Madagascar in 2005 to that in 2009?
Provide a succinct answer. 0.79. What is the ratio of the Rating index(maximum value in 2004 = 100) of Mauritius in 2005 to that in 2009?
Ensure brevity in your answer.  0.83. What is the ratio of the Rating index(maximum value in 2004 = 100) of India in 2005 to that in 2010?
Make the answer very short. 0.89. What is the ratio of the Rating index(maximum value in 2004 = 100) of Madagascar in 2005 to that in 2010?
Your answer should be compact. 0.93. What is the ratio of the Rating index(maximum value in 2004 = 100) in Mauritius in 2005 to that in 2010?
Provide a succinct answer. 0.73. What is the ratio of the Rating index(maximum value in 2004 = 100) in India in 2005 to that in 2011?
Give a very brief answer. 0.89. What is the ratio of the Rating index(maximum value in 2004 = 100) of Madagascar in 2005 to that in 2011?
Offer a very short reply. 0.88. What is the ratio of the Rating index(maximum value in 2004 = 100) of Mauritius in 2005 to that in 2011?
Give a very brief answer. 0.8. What is the ratio of the Rating index(maximum value in 2004 = 100) of India in 2005 to that in 2012?
Ensure brevity in your answer.  0.89. What is the ratio of the Rating index(maximum value in 2004 = 100) in Madagascar in 2005 to that in 2012?
Give a very brief answer. 0.58. What is the ratio of the Rating index(maximum value in 2004 = 100) in Mauritius in 2005 to that in 2012?
Provide a succinct answer. 0.51. What is the ratio of the Rating index(maximum value in 2004 = 100) of India in 2006 to that in 2007?
Offer a very short reply. 1.06. What is the ratio of the Rating index(maximum value in 2004 = 100) of Madagascar in 2006 to that in 2007?
Offer a terse response. 1.04. What is the ratio of the Rating index(maximum value in 2004 = 100) in Mauritius in 2006 to that in 2007?
Make the answer very short. 0.67. What is the ratio of the Rating index(maximum value in 2004 = 100) in India in 2006 to that in 2008?
Offer a terse response. 1.02. What is the ratio of the Rating index(maximum value in 2004 = 100) in Madagascar in 2006 to that in 2008?
Make the answer very short. 1.06. What is the ratio of the Rating index(maximum value in 2004 = 100) in Mauritius in 2006 to that in 2008?
Your answer should be very brief. 0.66. What is the ratio of the Rating index(maximum value in 2004 = 100) of India in 2006 to that in 2009?
Make the answer very short. 1.05. What is the ratio of the Rating index(maximum value in 2004 = 100) in Madagascar in 2006 to that in 2009?
Provide a succinct answer. 0.96. What is the ratio of the Rating index(maximum value in 2004 = 100) of Mauritius in 2006 to that in 2009?
Your answer should be very brief. 0.78. What is the ratio of the Rating index(maximum value in 2004 = 100) of India in 2006 to that in 2010?
Provide a short and direct response. 1.04. What is the ratio of the Rating index(maximum value in 2004 = 100) of Madagascar in 2006 to that in 2010?
Your answer should be very brief. 1.13. What is the ratio of the Rating index(maximum value in 2004 = 100) in Mauritius in 2006 to that in 2010?
Provide a succinct answer. 0.69. What is the ratio of the Rating index(maximum value in 2004 = 100) in India in 2006 to that in 2011?
Your answer should be compact. 1.03. What is the ratio of the Rating index(maximum value in 2004 = 100) in Madagascar in 2006 to that in 2011?
Your answer should be very brief. 1.08. What is the ratio of the Rating index(maximum value in 2004 = 100) of Mauritius in 2006 to that in 2011?
Your response must be concise. 0.75. What is the ratio of the Rating index(maximum value in 2004 = 100) in India in 2006 to that in 2012?
Your response must be concise. 1.04. What is the ratio of the Rating index(maximum value in 2004 = 100) of Madagascar in 2006 to that in 2012?
Your answer should be compact. 0.7. What is the ratio of the Rating index(maximum value in 2004 = 100) in Mauritius in 2006 to that in 2012?
Your answer should be very brief. 0.48. What is the ratio of the Rating index(maximum value in 2004 = 100) in India in 2007 to that in 2008?
Provide a short and direct response. 0.96. What is the ratio of the Rating index(maximum value in 2004 = 100) in Madagascar in 2007 to that in 2008?
Offer a very short reply. 1.02. What is the ratio of the Rating index(maximum value in 2004 = 100) in Mauritius in 2007 to that in 2008?
Offer a terse response. 0.99. What is the ratio of the Rating index(maximum value in 2004 = 100) of Madagascar in 2007 to that in 2009?
Provide a succinct answer. 0.92. What is the ratio of the Rating index(maximum value in 2004 = 100) of Mauritius in 2007 to that in 2009?
Provide a short and direct response. 1.16. What is the ratio of the Rating index(maximum value in 2004 = 100) of India in 2007 to that in 2010?
Your answer should be very brief. 0.98. What is the ratio of the Rating index(maximum value in 2004 = 100) in Madagascar in 2007 to that in 2010?
Offer a very short reply. 1.08. What is the ratio of the Rating index(maximum value in 2004 = 100) of Mauritius in 2007 to that in 2010?
Make the answer very short. 1.03. What is the ratio of the Rating index(maximum value in 2004 = 100) of India in 2007 to that in 2011?
Make the answer very short. 0.97. What is the ratio of the Rating index(maximum value in 2004 = 100) in Madagascar in 2007 to that in 2011?
Offer a very short reply. 1.03. What is the ratio of the Rating index(maximum value in 2004 = 100) in Mauritius in 2007 to that in 2011?
Provide a succinct answer. 1.12. What is the ratio of the Rating index(maximum value in 2004 = 100) in India in 2007 to that in 2012?
Make the answer very short. 0.98. What is the ratio of the Rating index(maximum value in 2004 = 100) in Madagascar in 2007 to that in 2012?
Offer a very short reply. 0.68. What is the ratio of the Rating index(maximum value in 2004 = 100) in Mauritius in 2007 to that in 2012?
Your answer should be compact. 0.72. What is the ratio of the Rating index(maximum value in 2004 = 100) in India in 2008 to that in 2009?
Ensure brevity in your answer.  1.03. What is the ratio of the Rating index(maximum value in 2004 = 100) of Madagascar in 2008 to that in 2009?
Your answer should be very brief. 0.91. What is the ratio of the Rating index(maximum value in 2004 = 100) of Mauritius in 2008 to that in 2009?
Give a very brief answer. 1.18. What is the ratio of the Rating index(maximum value in 2004 = 100) of India in 2008 to that in 2010?
Your response must be concise. 1.02. What is the ratio of the Rating index(maximum value in 2004 = 100) of Madagascar in 2008 to that in 2010?
Give a very brief answer. 1.06. What is the ratio of the Rating index(maximum value in 2004 = 100) in Mauritius in 2008 to that in 2010?
Keep it short and to the point. 1.04. What is the ratio of the Rating index(maximum value in 2004 = 100) of India in 2008 to that in 2011?
Your answer should be compact. 1.02. What is the ratio of the Rating index(maximum value in 2004 = 100) of Mauritius in 2008 to that in 2011?
Keep it short and to the point. 1.13. What is the ratio of the Rating index(maximum value in 2004 = 100) of India in 2008 to that in 2012?
Offer a terse response. 1.02. What is the ratio of the Rating index(maximum value in 2004 = 100) in Madagascar in 2008 to that in 2012?
Your answer should be compact. 0.66. What is the ratio of the Rating index(maximum value in 2004 = 100) in Mauritius in 2008 to that in 2012?
Your response must be concise. 0.73. What is the ratio of the Rating index(maximum value in 2004 = 100) in Madagascar in 2009 to that in 2010?
Offer a terse response. 1.17. What is the ratio of the Rating index(maximum value in 2004 = 100) of Mauritius in 2009 to that in 2010?
Keep it short and to the point. 0.88. What is the ratio of the Rating index(maximum value in 2004 = 100) of Madagascar in 2009 to that in 2011?
Provide a short and direct response. 1.12. What is the ratio of the Rating index(maximum value in 2004 = 100) of Mauritius in 2009 to that in 2011?
Your response must be concise. 0.96. What is the ratio of the Rating index(maximum value in 2004 = 100) in India in 2009 to that in 2012?
Keep it short and to the point. 0.99. What is the ratio of the Rating index(maximum value in 2004 = 100) in Madagascar in 2009 to that in 2012?
Offer a very short reply. 0.73. What is the ratio of the Rating index(maximum value in 2004 = 100) of Mauritius in 2009 to that in 2012?
Give a very brief answer. 0.62. What is the ratio of the Rating index(maximum value in 2004 = 100) of India in 2010 to that in 2011?
Your response must be concise. 1. What is the ratio of the Rating index(maximum value in 2004 = 100) of Madagascar in 2010 to that in 2011?
Your answer should be compact. 0.96. What is the ratio of the Rating index(maximum value in 2004 = 100) of Mauritius in 2010 to that in 2011?
Your answer should be very brief. 1.09. What is the ratio of the Rating index(maximum value in 2004 = 100) of India in 2010 to that in 2012?
Provide a succinct answer. 1. What is the ratio of the Rating index(maximum value in 2004 = 100) of Madagascar in 2010 to that in 2012?
Offer a very short reply. 0.63. What is the ratio of the Rating index(maximum value in 2004 = 100) of Mauritius in 2010 to that in 2012?
Your answer should be very brief. 0.7. What is the ratio of the Rating index(maximum value in 2004 = 100) in India in 2011 to that in 2012?
Provide a short and direct response. 1.01. What is the ratio of the Rating index(maximum value in 2004 = 100) of Madagascar in 2011 to that in 2012?
Ensure brevity in your answer.  0.65. What is the ratio of the Rating index(maximum value in 2004 = 100) of Mauritius in 2011 to that in 2012?
Give a very brief answer. 0.64. What is the difference between the highest and the second highest Rating index(maximum value in 2004 = 100) in India?
Give a very brief answer. 0.72. What is the difference between the highest and the second highest Rating index(maximum value in 2004 = 100) of Madagascar?
Offer a very short reply. 3.16. What is the difference between the highest and the second highest Rating index(maximum value in 2004 = 100) of Mauritius?
Ensure brevity in your answer.  6.43. What is the difference between the highest and the lowest Rating index(maximum value in 2004 = 100) in India?
Your answer should be compact. 6.02. What is the difference between the highest and the lowest Rating index(maximum value in 2004 = 100) in Madagascar?
Make the answer very short. 4.97. What is the difference between the highest and the lowest Rating index(maximum value in 2004 = 100) of Mauritius?
Ensure brevity in your answer.  12.33. 